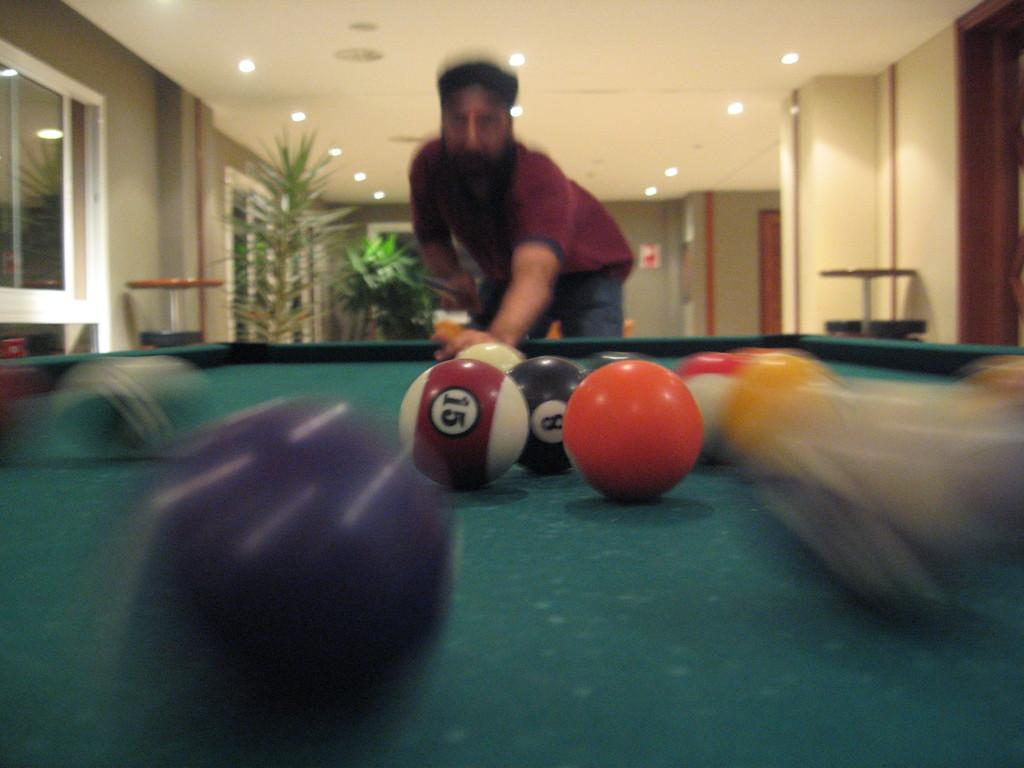What is the main subject of the image? There is a man standing in the image. What is the man wearing? The man is wearing clothes. What objects related to the game of snooker can be seen in the image? There are snooker balls and a snooker table in the image. What other elements are present in the image? There is a plant, lights, windows, and possibly more. How many women are participating in the rainstorm depicted in the image? There is no rainstorm or women present in the image; it features a man standing near a snooker table with snooker balls and other elements. 